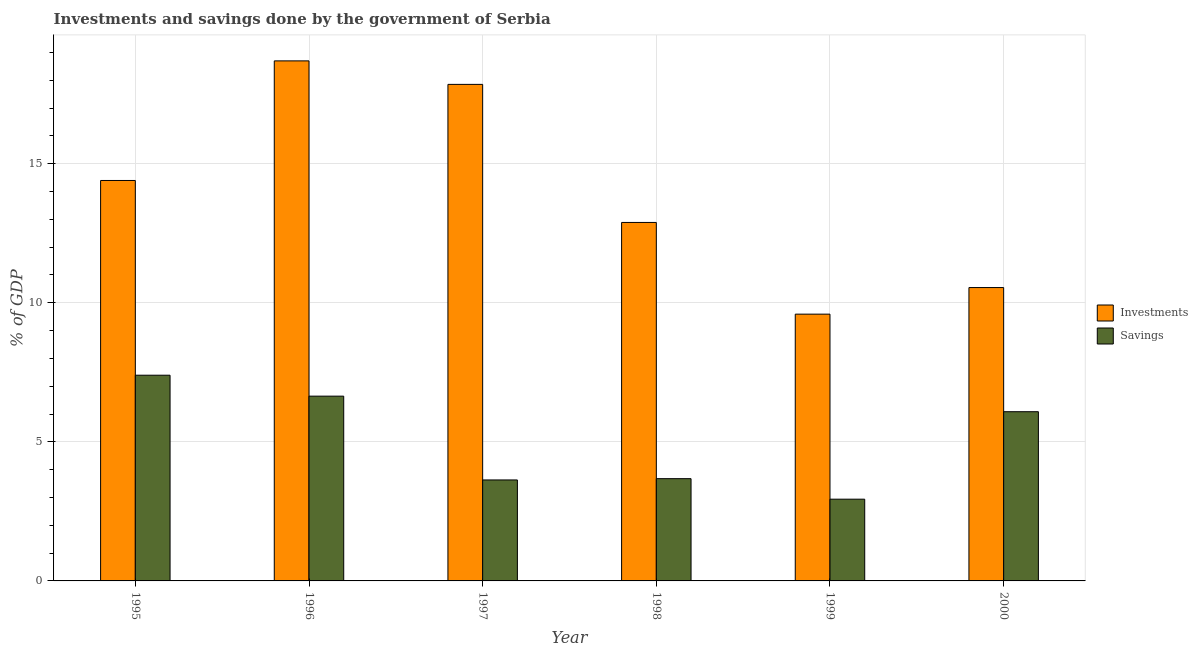How many groups of bars are there?
Your answer should be very brief. 6. Are the number of bars per tick equal to the number of legend labels?
Make the answer very short. Yes. What is the label of the 6th group of bars from the left?
Ensure brevity in your answer.  2000. In how many cases, is the number of bars for a given year not equal to the number of legend labels?
Your answer should be compact. 0. What is the savings of government in 2000?
Ensure brevity in your answer.  6.08. Across all years, what is the maximum savings of government?
Your answer should be compact. 7.4. Across all years, what is the minimum savings of government?
Your answer should be compact. 2.94. In which year was the savings of government maximum?
Your response must be concise. 1995. In which year was the savings of government minimum?
Give a very brief answer. 1999. What is the total savings of government in the graph?
Give a very brief answer. 30.37. What is the difference between the savings of government in 1995 and that in 1999?
Offer a terse response. 4.46. What is the difference between the investments of government in 1995 and the savings of government in 2000?
Ensure brevity in your answer.  3.85. What is the average savings of government per year?
Your response must be concise. 5.06. In the year 1995, what is the difference between the savings of government and investments of government?
Ensure brevity in your answer.  0. In how many years, is the savings of government greater than 12 %?
Provide a short and direct response. 0. What is the ratio of the savings of government in 1995 to that in 1996?
Give a very brief answer. 1.11. Is the savings of government in 1998 less than that in 2000?
Ensure brevity in your answer.  Yes. Is the difference between the savings of government in 1996 and 1999 greater than the difference between the investments of government in 1996 and 1999?
Provide a succinct answer. No. What is the difference between the highest and the second highest investments of government?
Your answer should be very brief. 0.85. What is the difference between the highest and the lowest investments of government?
Your answer should be compact. 9.11. In how many years, is the savings of government greater than the average savings of government taken over all years?
Your answer should be very brief. 3. Is the sum of the savings of government in 1998 and 2000 greater than the maximum investments of government across all years?
Your answer should be compact. Yes. What does the 2nd bar from the left in 1995 represents?
Provide a succinct answer. Savings. What does the 1st bar from the right in 1998 represents?
Provide a short and direct response. Savings. Are all the bars in the graph horizontal?
Offer a terse response. No. How many years are there in the graph?
Provide a short and direct response. 6. What is the difference between two consecutive major ticks on the Y-axis?
Offer a very short reply. 5. Does the graph contain grids?
Your response must be concise. Yes. Where does the legend appear in the graph?
Keep it short and to the point. Center right. How many legend labels are there?
Keep it short and to the point. 2. What is the title of the graph?
Offer a very short reply. Investments and savings done by the government of Serbia. What is the label or title of the X-axis?
Provide a succinct answer. Year. What is the label or title of the Y-axis?
Ensure brevity in your answer.  % of GDP. What is the % of GDP in Investments in 1995?
Ensure brevity in your answer.  14.4. What is the % of GDP of Savings in 1995?
Your answer should be compact. 7.4. What is the % of GDP of Investments in 1996?
Provide a succinct answer. 18.7. What is the % of GDP of Savings in 1996?
Your response must be concise. 6.64. What is the % of GDP of Investments in 1997?
Make the answer very short. 17.85. What is the % of GDP in Savings in 1997?
Offer a very short reply. 3.63. What is the % of GDP of Investments in 1998?
Offer a terse response. 12.89. What is the % of GDP of Savings in 1998?
Ensure brevity in your answer.  3.68. What is the % of GDP in Investments in 1999?
Provide a succinct answer. 9.59. What is the % of GDP in Savings in 1999?
Ensure brevity in your answer.  2.94. What is the % of GDP of Investments in 2000?
Your response must be concise. 10.55. What is the % of GDP in Savings in 2000?
Your answer should be compact. 6.08. Across all years, what is the maximum % of GDP in Investments?
Provide a short and direct response. 18.7. Across all years, what is the maximum % of GDP of Savings?
Give a very brief answer. 7.4. Across all years, what is the minimum % of GDP of Investments?
Your answer should be very brief. 9.59. Across all years, what is the minimum % of GDP in Savings?
Provide a short and direct response. 2.94. What is the total % of GDP of Investments in the graph?
Offer a terse response. 83.98. What is the total % of GDP of Savings in the graph?
Your answer should be compact. 30.37. What is the difference between the % of GDP of Investments in 1995 and that in 1996?
Provide a short and direct response. -4.3. What is the difference between the % of GDP in Savings in 1995 and that in 1996?
Give a very brief answer. 0.75. What is the difference between the % of GDP in Investments in 1995 and that in 1997?
Provide a succinct answer. -3.46. What is the difference between the % of GDP of Savings in 1995 and that in 1997?
Give a very brief answer. 3.77. What is the difference between the % of GDP of Investments in 1995 and that in 1998?
Ensure brevity in your answer.  1.51. What is the difference between the % of GDP in Savings in 1995 and that in 1998?
Give a very brief answer. 3.72. What is the difference between the % of GDP in Investments in 1995 and that in 1999?
Offer a very short reply. 4.81. What is the difference between the % of GDP in Savings in 1995 and that in 1999?
Make the answer very short. 4.46. What is the difference between the % of GDP of Investments in 1995 and that in 2000?
Your answer should be compact. 3.85. What is the difference between the % of GDP of Savings in 1995 and that in 2000?
Offer a terse response. 1.31. What is the difference between the % of GDP of Investments in 1996 and that in 1997?
Your response must be concise. 0.84. What is the difference between the % of GDP in Savings in 1996 and that in 1997?
Offer a terse response. 3.01. What is the difference between the % of GDP of Investments in 1996 and that in 1998?
Make the answer very short. 5.81. What is the difference between the % of GDP in Savings in 1996 and that in 1998?
Provide a short and direct response. 2.97. What is the difference between the % of GDP of Investments in 1996 and that in 1999?
Your answer should be compact. 9.11. What is the difference between the % of GDP of Savings in 1996 and that in 1999?
Offer a terse response. 3.7. What is the difference between the % of GDP of Investments in 1996 and that in 2000?
Provide a short and direct response. 8.15. What is the difference between the % of GDP in Savings in 1996 and that in 2000?
Provide a succinct answer. 0.56. What is the difference between the % of GDP of Investments in 1997 and that in 1998?
Offer a very short reply. 4.96. What is the difference between the % of GDP of Savings in 1997 and that in 1998?
Make the answer very short. -0.05. What is the difference between the % of GDP of Investments in 1997 and that in 1999?
Your response must be concise. 8.26. What is the difference between the % of GDP of Savings in 1997 and that in 1999?
Provide a succinct answer. 0.69. What is the difference between the % of GDP in Investments in 1997 and that in 2000?
Make the answer very short. 7.3. What is the difference between the % of GDP of Savings in 1997 and that in 2000?
Provide a succinct answer. -2.45. What is the difference between the % of GDP of Investments in 1998 and that in 1999?
Your response must be concise. 3.3. What is the difference between the % of GDP in Savings in 1998 and that in 1999?
Ensure brevity in your answer.  0.74. What is the difference between the % of GDP in Investments in 1998 and that in 2000?
Ensure brevity in your answer.  2.34. What is the difference between the % of GDP of Savings in 1998 and that in 2000?
Your response must be concise. -2.41. What is the difference between the % of GDP in Investments in 1999 and that in 2000?
Ensure brevity in your answer.  -0.96. What is the difference between the % of GDP in Savings in 1999 and that in 2000?
Your response must be concise. -3.15. What is the difference between the % of GDP of Investments in 1995 and the % of GDP of Savings in 1996?
Keep it short and to the point. 7.75. What is the difference between the % of GDP of Investments in 1995 and the % of GDP of Savings in 1997?
Your response must be concise. 10.77. What is the difference between the % of GDP in Investments in 1995 and the % of GDP in Savings in 1998?
Offer a very short reply. 10.72. What is the difference between the % of GDP of Investments in 1995 and the % of GDP of Savings in 1999?
Provide a succinct answer. 11.46. What is the difference between the % of GDP of Investments in 1995 and the % of GDP of Savings in 2000?
Offer a very short reply. 8.31. What is the difference between the % of GDP in Investments in 1996 and the % of GDP in Savings in 1997?
Your answer should be very brief. 15.07. What is the difference between the % of GDP of Investments in 1996 and the % of GDP of Savings in 1998?
Provide a short and direct response. 15.02. What is the difference between the % of GDP in Investments in 1996 and the % of GDP in Savings in 1999?
Keep it short and to the point. 15.76. What is the difference between the % of GDP of Investments in 1996 and the % of GDP of Savings in 2000?
Offer a terse response. 12.61. What is the difference between the % of GDP in Investments in 1997 and the % of GDP in Savings in 1998?
Keep it short and to the point. 14.18. What is the difference between the % of GDP in Investments in 1997 and the % of GDP in Savings in 1999?
Your response must be concise. 14.91. What is the difference between the % of GDP of Investments in 1997 and the % of GDP of Savings in 2000?
Your response must be concise. 11.77. What is the difference between the % of GDP of Investments in 1998 and the % of GDP of Savings in 1999?
Your answer should be compact. 9.95. What is the difference between the % of GDP in Investments in 1998 and the % of GDP in Savings in 2000?
Ensure brevity in your answer.  6.8. What is the difference between the % of GDP of Investments in 1999 and the % of GDP of Savings in 2000?
Ensure brevity in your answer.  3.51. What is the average % of GDP in Investments per year?
Your answer should be very brief. 14. What is the average % of GDP of Savings per year?
Your answer should be compact. 5.06. In the year 1995, what is the difference between the % of GDP in Investments and % of GDP in Savings?
Provide a short and direct response. 7. In the year 1996, what is the difference between the % of GDP in Investments and % of GDP in Savings?
Ensure brevity in your answer.  12.05. In the year 1997, what is the difference between the % of GDP in Investments and % of GDP in Savings?
Ensure brevity in your answer.  14.22. In the year 1998, what is the difference between the % of GDP in Investments and % of GDP in Savings?
Keep it short and to the point. 9.21. In the year 1999, what is the difference between the % of GDP of Investments and % of GDP of Savings?
Your answer should be compact. 6.65. In the year 2000, what is the difference between the % of GDP of Investments and % of GDP of Savings?
Offer a terse response. 4.46. What is the ratio of the % of GDP in Investments in 1995 to that in 1996?
Provide a succinct answer. 0.77. What is the ratio of the % of GDP in Savings in 1995 to that in 1996?
Give a very brief answer. 1.11. What is the ratio of the % of GDP in Investments in 1995 to that in 1997?
Make the answer very short. 0.81. What is the ratio of the % of GDP in Savings in 1995 to that in 1997?
Make the answer very short. 2.04. What is the ratio of the % of GDP in Investments in 1995 to that in 1998?
Provide a succinct answer. 1.12. What is the ratio of the % of GDP of Savings in 1995 to that in 1998?
Make the answer very short. 2.01. What is the ratio of the % of GDP of Investments in 1995 to that in 1999?
Your answer should be very brief. 1.5. What is the ratio of the % of GDP of Savings in 1995 to that in 1999?
Ensure brevity in your answer.  2.52. What is the ratio of the % of GDP of Investments in 1995 to that in 2000?
Offer a very short reply. 1.36. What is the ratio of the % of GDP in Savings in 1995 to that in 2000?
Offer a very short reply. 1.22. What is the ratio of the % of GDP of Investments in 1996 to that in 1997?
Your answer should be compact. 1.05. What is the ratio of the % of GDP in Savings in 1996 to that in 1997?
Your answer should be compact. 1.83. What is the ratio of the % of GDP of Investments in 1996 to that in 1998?
Offer a terse response. 1.45. What is the ratio of the % of GDP of Savings in 1996 to that in 1998?
Your answer should be compact. 1.81. What is the ratio of the % of GDP of Investments in 1996 to that in 1999?
Give a very brief answer. 1.95. What is the ratio of the % of GDP of Savings in 1996 to that in 1999?
Your response must be concise. 2.26. What is the ratio of the % of GDP in Investments in 1996 to that in 2000?
Make the answer very short. 1.77. What is the ratio of the % of GDP of Savings in 1996 to that in 2000?
Make the answer very short. 1.09. What is the ratio of the % of GDP in Investments in 1997 to that in 1998?
Offer a very short reply. 1.39. What is the ratio of the % of GDP of Savings in 1997 to that in 1998?
Give a very brief answer. 0.99. What is the ratio of the % of GDP of Investments in 1997 to that in 1999?
Offer a terse response. 1.86. What is the ratio of the % of GDP in Savings in 1997 to that in 1999?
Ensure brevity in your answer.  1.24. What is the ratio of the % of GDP in Investments in 1997 to that in 2000?
Offer a very short reply. 1.69. What is the ratio of the % of GDP in Savings in 1997 to that in 2000?
Your answer should be compact. 0.6. What is the ratio of the % of GDP of Investments in 1998 to that in 1999?
Ensure brevity in your answer.  1.34. What is the ratio of the % of GDP of Savings in 1998 to that in 1999?
Provide a succinct answer. 1.25. What is the ratio of the % of GDP in Investments in 1998 to that in 2000?
Keep it short and to the point. 1.22. What is the ratio of the % of GDP in Savings in 1998 to that in 2000?
Ensure brevity in your answer.  0.6. What is the ratio of the % of GDP in Investments in 1999 to that in 2000?
Keep it short and to the point. 0.91. What is the ratio of the % of GDP in Savings in 1999 to that in 2000?
Offer a very short reply. 0.48. What is the difference between the highest and the second highest % of GDP of Investments?
Your answer should be compact. 0.84. What is the difference between the highest and the second highest % of GDP of Savings?
Your answer should be compact. 0.75. What is the difference between the highest and the lowest % of GDP of Investments?
Your answer should be compact. 9.11. What is the difference between the highest and the lowest % of GDP of Savings?
Give a very brief answer. 4.46. 